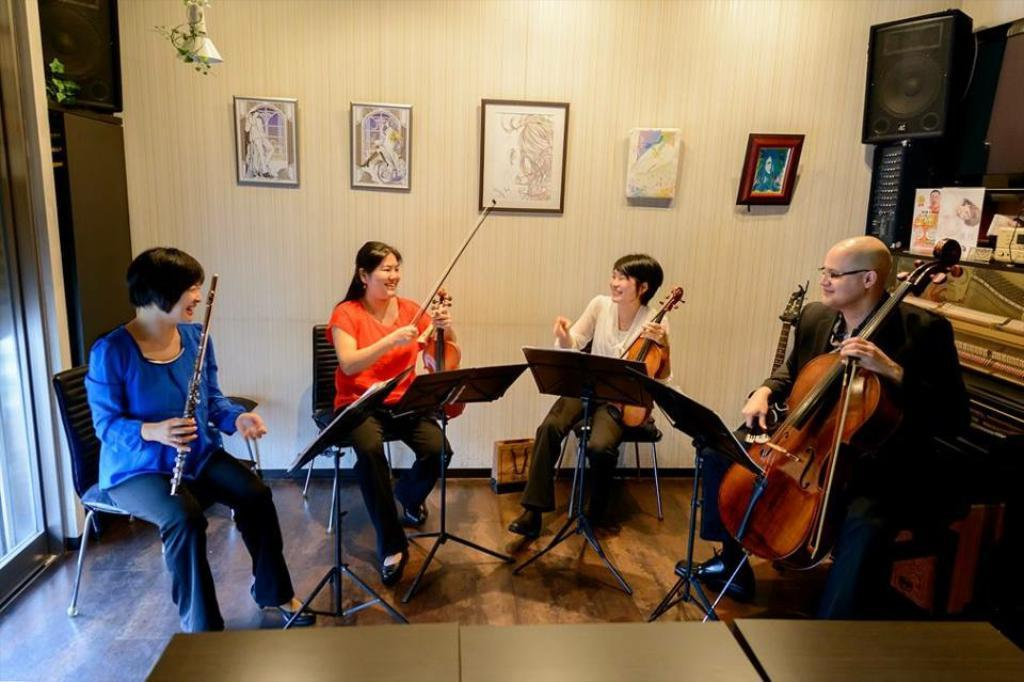Who is present in the image? There are people in the image. What are the people doing in the image? The people are sitting on chairs and playing musical instruments. What type of food is being served in the image? There is no food present in the image; it features people sitting on chairs and playing musical instruments. How many arms are visible in the image? The number of arms visible in the image cannot be determined from the provided facts, as the focus is on the people and their actions, not their body parts. 